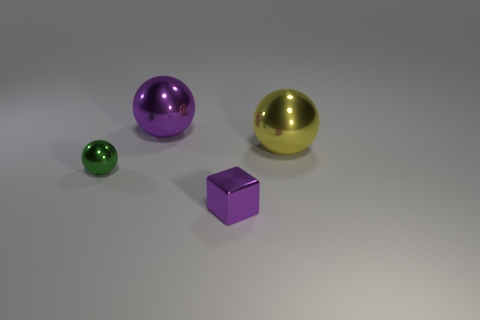How many balls are either small blue matte things or small objects? In the image, there are a total of four objects. Of these, three are balls, but none of them are blue. The objects include one small green ball, one medium-sized purple shiny sphere, and one larger shiny golden sphere. There is also one small matte purple cube. So, the answer to your question is one, as there is only one small ball, which is green. 